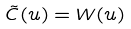Convert formula to latex. <formula><loc_0><loc_0><loc_500><loc_500>\tilde { C } ( u ) = W ( u )</formula> 